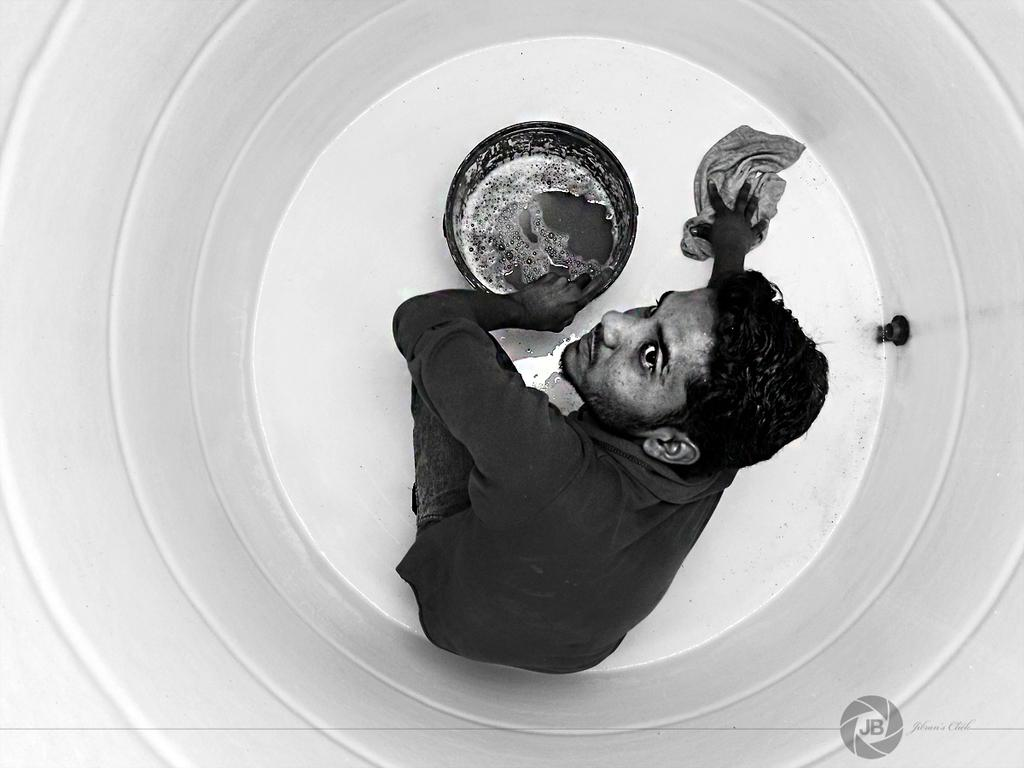What is the main subject of the image? The image shows an inside view of a tank. Is there anyone inside the tank? Yes, there is a man sitting in the tank. What objects can be seen in the image besides the man? There is a bucket and a cloth in the image. What is inside the bucket? There is water in the bucket. What type of powder can be seen in the image? There is no powder present in the image. What does the image smell like? The image does not have a smell, as it is a visual representation. 